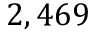<formula> <loc_0><loc_0><loc_500><loc_500>2 , 4 6 9</formula> 